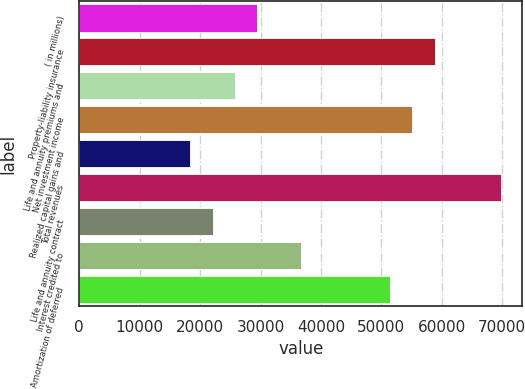Convert chart. <chart><loc_0><loc_0><loc_500><loc_500><bar_chart><fcel>( in millions)<fcel>Property-liability insurance<fcel>Life and annuity premiums and<fcel>Net investment income<fcel>Realized capital gains and<fcel>Total revenues<fcel>Life and annuity contract<fcel>Interest credited to<fcel>Amortization of deferred<nl><fcel>29417.2<fcel>58824.4<fcel>25741.3<fcel>55148.5<fcel>18389.5<fcel>69852.1<fcel>22065.4<fcel>36769<fcel>51472.6<nl></chart> 